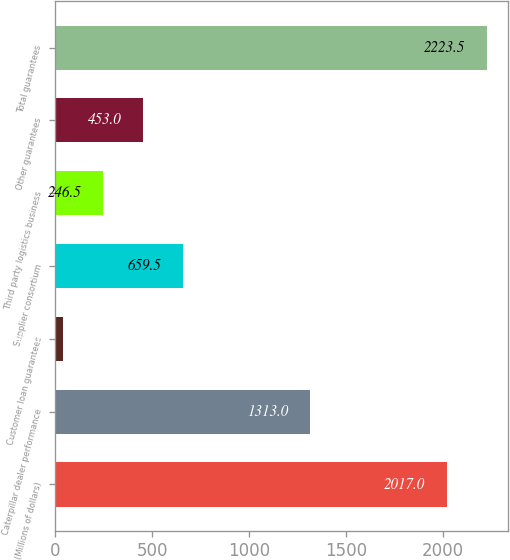<chart> <loc_0><loc_0><loc_500><loc_500><bar_chart><fcel>(Millions of dollars)<fcel>Caterpillar dealer performance<fcel>Customer loan guarantees<fcel>Supplier consortium<fcel>Third party logistics business<fcel>Other guarantees<fcel>Total guarantees<nl><fcel>2017<fcel>1313<fcel>40<fcel>659.5<fcel>246.5<fcel>453<fcel>2223.5<nl></chart> 